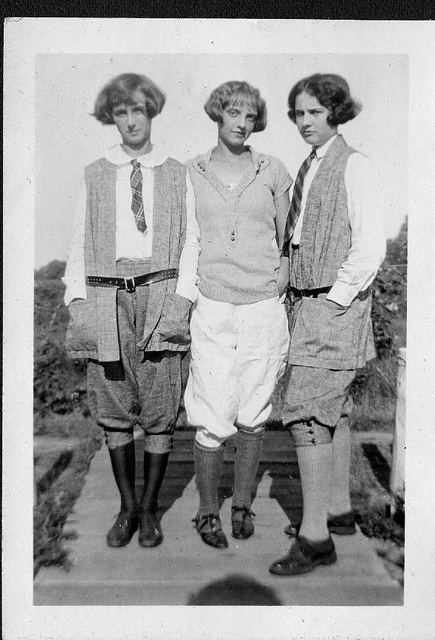Describe the objects in this image and their specific colors. I can see people in black, darkgray, gray, and lightgray tones, people in black, darkgray, lightgray, and gray tones, people in black, lightgray, darkgray, and gray tones, tie in black, gray, darkgray, and lightgray tones, and tie in darkgray, gray, lightgray, and black tones in this image. 